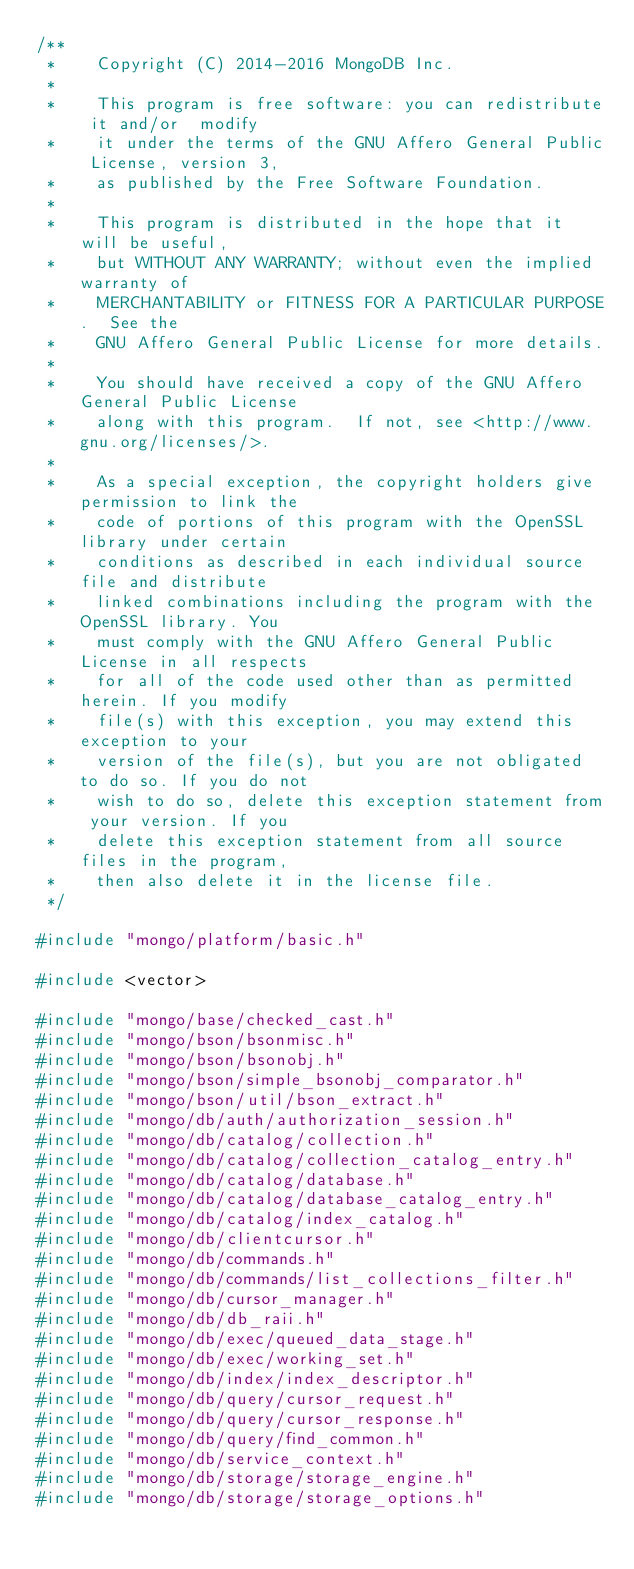<code> <loc_0><loc_0><loc_500><loc_500><_C++_>/**
 *    Copyright (C) 2014-2016 MongoDB Inc.
 *
 *    This program is free software: you can redistribute it and/or  modify
 *    it under the terms of the GNU Affero General Public License, version 3,
 *    as published by the Free Software Foundation.
 *
 *    This program is distributed in the hope that it will be useful,
 *    but WITHOUT ANY WARRANTY; without even the implied warranty of
 *    MERCHANTABILITY or FITNESS FOR A PARTICULAR PURPOSE.  See the
 *    GNU Affero General Public License for more details.
 *
 *    You should have received a copy of the GNU Affero General Public License
 *    along with this program.  If not, see <http://www.gnu.org/licenses/>.
 *
 *    As a special exception, the copyright holders give permission to link the
 *    code of portions of this program with the OpenSSL library under certain
 *    conditions as described in each individual source file and distribute
 *    linked combinations including the program with the OpenSSL library. You
 *    must comply with the GNU Affero General Public License in all respects
 *    for all of the code used other than as permitted herein. If you modify
 *    file(s) with this exception, you may extend this exception to your
 *    version of the file(s), but you are not obligated to do so. If you do not
 *    wish to do so, delete this exception statement from your version. If you
 *    delete this exception statement from all source files in the program,
 *    then also delete it in the license file.
 */

#include "mongo/platform/basic.h"

#include <vector>

#include "mongo/base/checked_cast.h"
#include "mongo/bson/bsonmisc.h"
#include "mongo/bson/bsonobj.h"
#include "mongo/bson/simple_bsonobj_comparator.h"
#include "mongo/bson/util/bson_extract.h"
#include "mongo/db/auth/authorization_session.h"
#include "mongo/db/catalog/collection.h"
#include "mongo/db/catalog/collection_catalog_entry.h"
#include "mongo/db/catalog/database.h"
#include "mongo/db/catalog/database_catalog_entry.h"
#include "mongo/db/catalog/index_catalog.h"
#include "mongo/db/clientcursor.h"
#include "mongo/db/commands.h"
#include "mongo/db/commands/list_collections_filter.h"
#include "mongo/db/cursor_manager.h"
#include "mongo/db/db_raii.h"
#include "mongo/db/exec/queued_data_stage.h"
#include "mongo/db/exec/working_set.h"
#include "mongo/db/index/index_descriptor.h"
#include "mongo/db/query/cursor_request.h"
#include "mongo/db/query/cursor_response.h"
#include "mongo/db/query/find_common.h"
#include "mongo/db/service_context.h"
#include "mongo/db/storage/storage_engine.h"
#include "mongo/db/storage/storage_options.h"</code> 